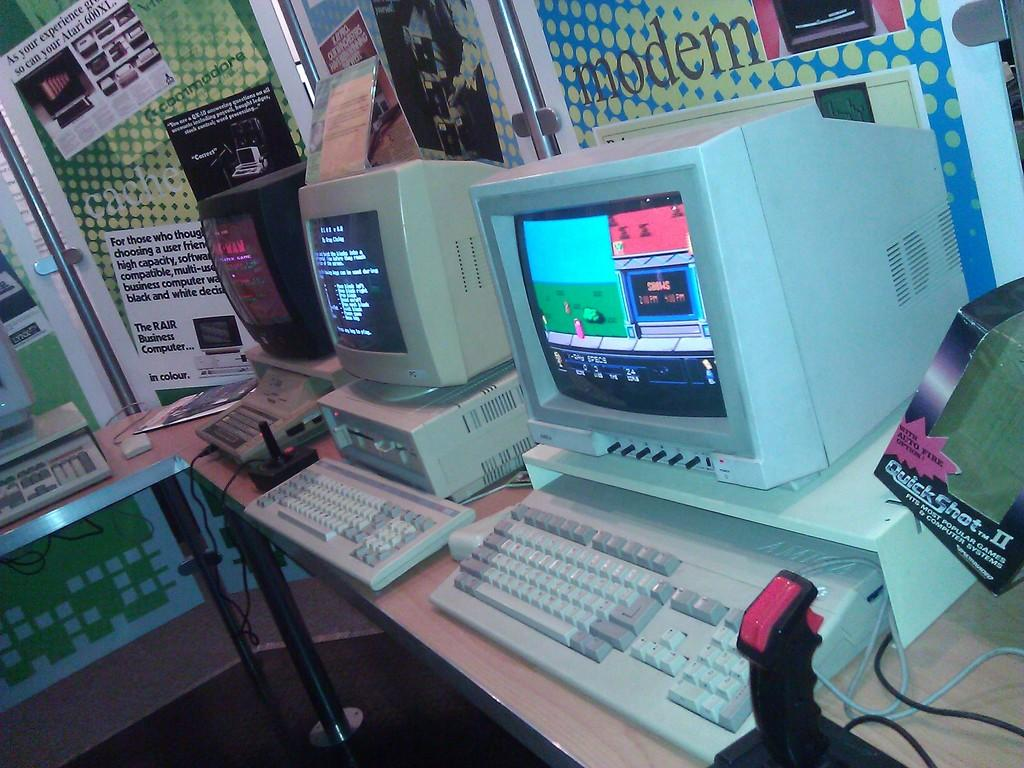<image>
Create a compact narrative representing the image presented. Old computers with the big back monitors sit in front of a sign that says modem. 